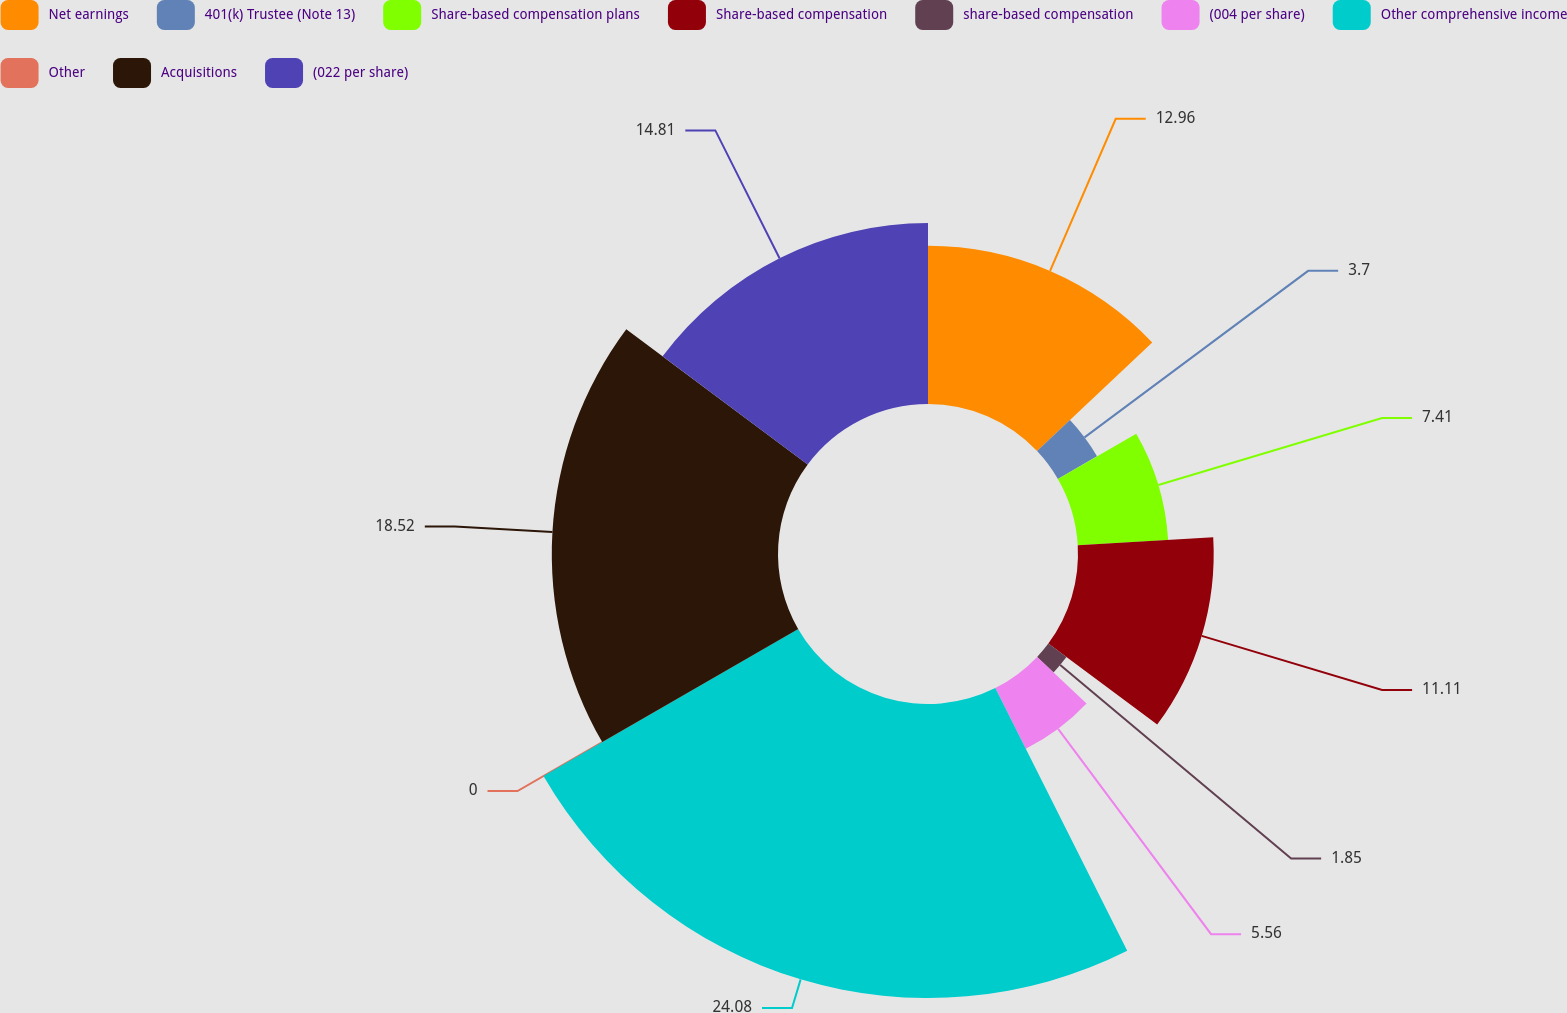<chart> <loc_0><loc_0><loc_500><loc_500><pie_chart><fcel>Net earnings<fcel>401(k) Trustee (Note 13)<fcel>Share-based compensation plans<fcel>Share-based compensation<fcel>share-based compensation<fcel>(004 per share)<fcel>Other comprehensive income<fcel>Other<fcel>Acquisitions<fcel>(022 per share)<nl><fcel>12.96%<fcel>3.7%<fcel>7.41%<fcel>11.11%<fcel>1.85%<fcel>5.56%<fcel>24.07%<fcel>0.0%<fcel>18.52%<fcel>14.81%<nl></chart> 